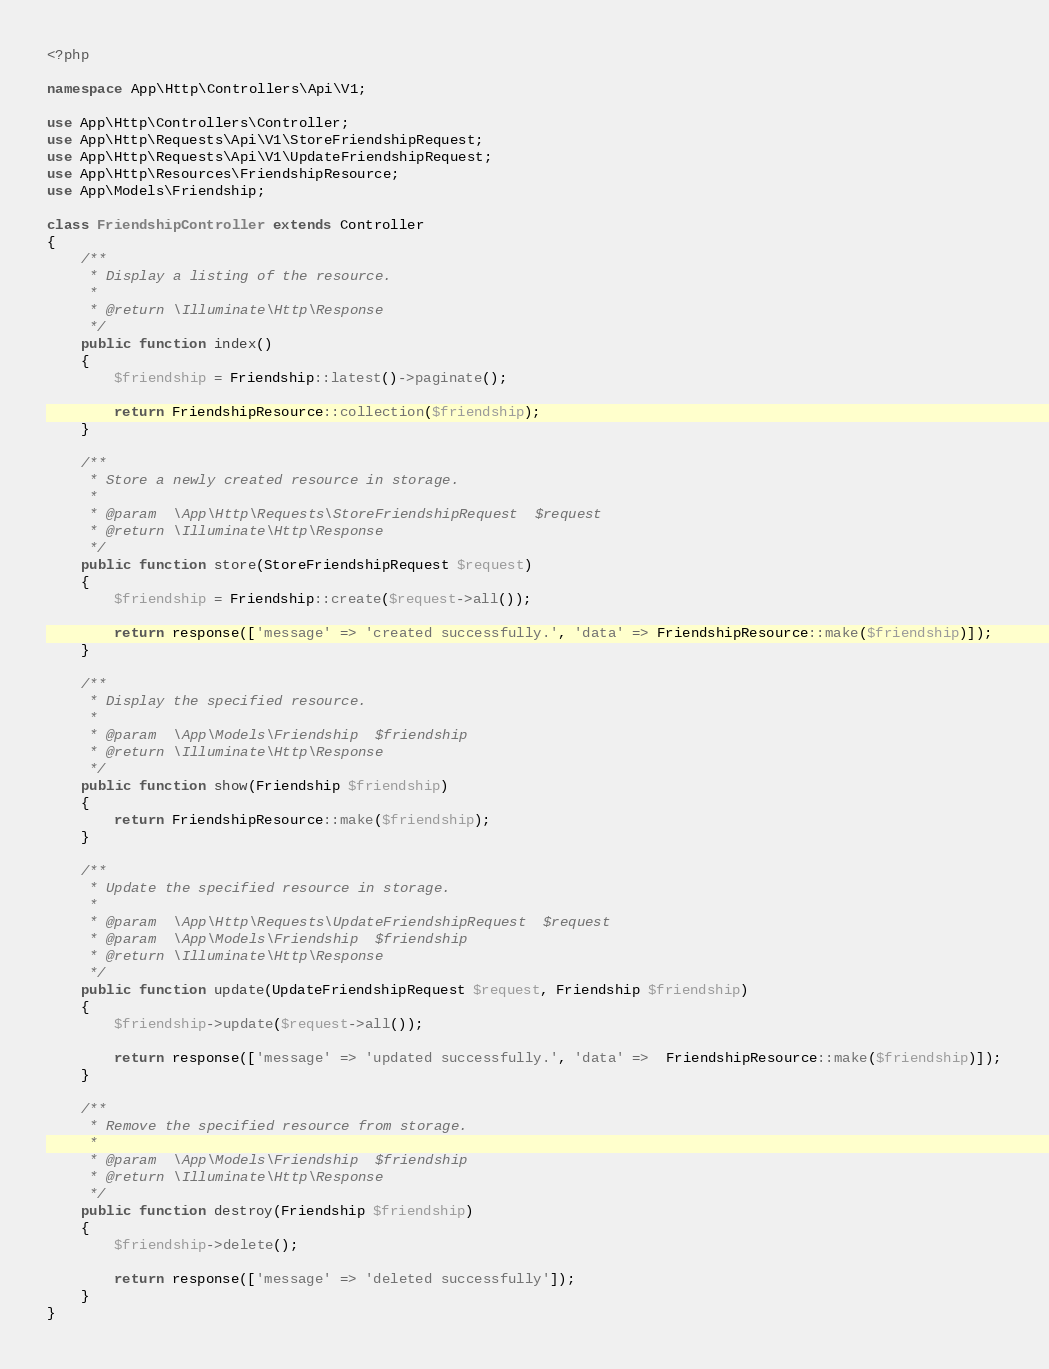Convert code to text. <code><loc_0><loc_0><loc_500><loc_500><_PHP_><?php

namespace App\Http\Controllers\Api\V1;

use App\Http\Controllers\Controller;
use App\Http\Requests\Api\V1\StoreFriendshipRequest;
use App\Http\Requests\Api\V1\UpdateFriendshipRequest;
use App\Http\Resources\FriendshipResource;
use App\Models\Friendship;

class FriendshipController extends Controller
{
    /**
     * Display a listing of the resource.
     *
     * @return \Illuminate\Http\Response
     */
    public function index()
    {
        $friendship = Friendship::latest()->paginate();

        return FriendshipResource::collection($friendship);
    }

    /**
     * Store a newly created resource in storage.
     *
     * @param  \App\Http\Requests\StoreFriendshipRequest  $request
     * @return \Illuminate\Http\Response
     */
    public function store(StoreFriendshipRequest $request)
    {
        $friendship = Friendship::create($request->all());

        return response(['message' => 'created successfully.', 'data' => FriendshipResource::make($friendship)]);
    }

    /**
     * Display the specified resource.
     *
     * @param  \App\Models\Friendship  $friendship
     * @return \Illuminate\Http\Response
     */
    public function show(Friendship $friendship)
    {
        return FriendshipResource::make($friendship);
    }

    /**
     * Update the specified resource in storage.
     *
     * @param  \App\Http\Requests\UpdateFriendshipRequest  $request
     * @param  \App\Models\Friendship  $friendship
     * @return \Illuminate\Http\Response
     */
    public function update(UpdateFriendshipRequest $request, Friendship $friendship)
    {
        $friendship->update($request->all());

        return response(['message' => 'updated successfully.', 'data' =>  FriendshipResource::make($friendship)]);
    }

    /**
     * Remove the specified resource from storage.
     *
     * @param  \App\Models\Friendship  $friendship
     * @return \Illuminate\Http\Response
     */
    public function destroy(Friendship $friendship)
    {
        $friendship->delete();

        return response(['message' => 'deleted successfully']);
    }
}
</code> 